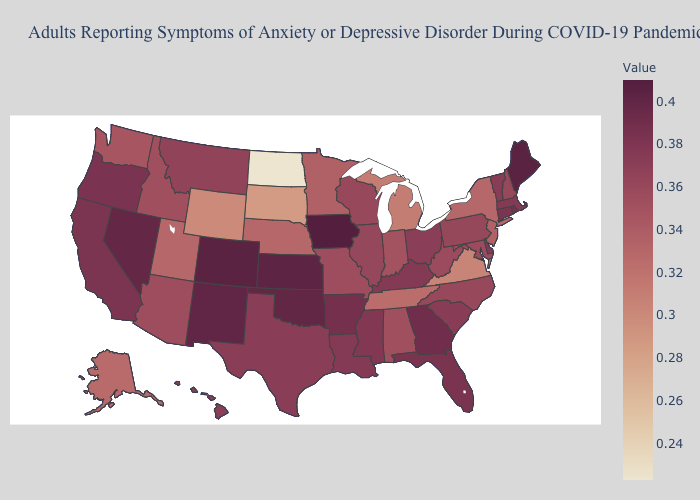Does Kansas have the highest value in the MidWest?
Short answer required. No. Does California have the lowest value in the West?
Write a very short answer. No. Does Missouri have a lower value than Virginia?
Keep it brief. No. Does New York have the lowest value in the Northeast?
Short answer required. Yes. Among the states that border Virginia , does Tennessee have the highest value?
Keep it brief. No. 